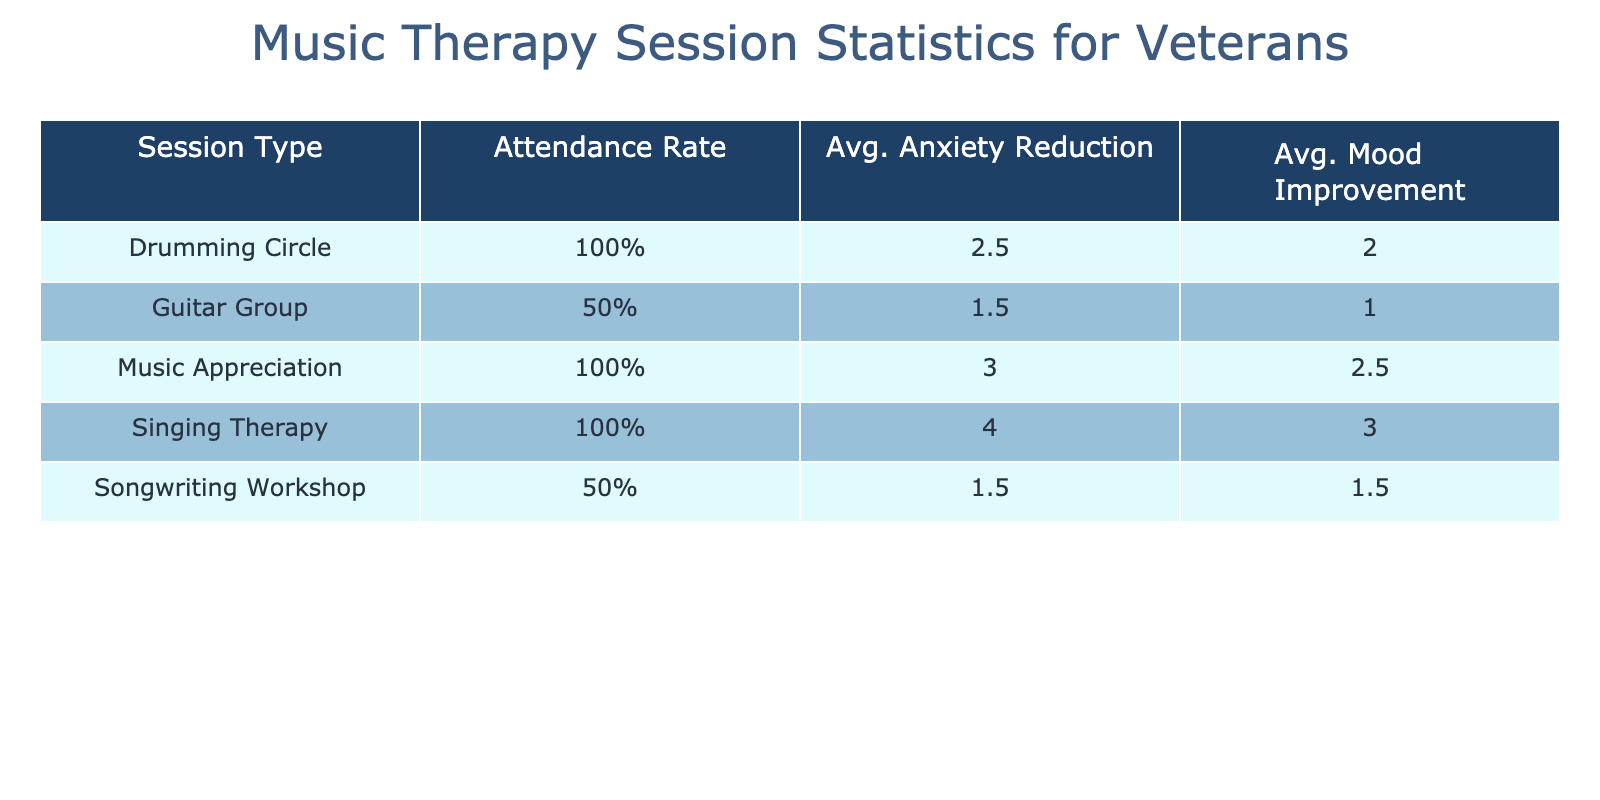What is the attendance rate for the Singing Therapy session type? Looking at the table, the Singing Therapy session had three veterans attending, and all three attended (i.e., 'Yes' for attendance), resulting in an attendance rate of 100%.
Answer: 100% What was the average anxiety reduction for the Drumming Circle session? In the table, the Anxiety Change for the Drumming Circle session (Veterans 001 and 006) is calculated as follows: Veteran 001 had an anxiety level change of 7 - 4 = 3, and Veteran 006 had a change of 4 - 2 = 2. The average is (3 + 2) / 2 = 2.5.
Answer: 2.5 Was there any decrease in mood level after attending the Guitar Group session? For the Guitar Group, only Veteran 008 attended and there is a change in mood level calculated as 6 - 4 = 2, which indicates an improvement in mood. Thus, there was no decrease in mood.
Answer: No What is the average mood improvement across all session types? To find the average mood improvement, we calculate the changes for each session type: Drumming Circle: 1.5, Songwriting Workshop: 3, Music Appreciation: 3, Singing Therapy: 3, and Guitar Group: 2. Since there are 5 sessions, the average improvement is (1.5 + 3 + 3 + 3 + 2) / 5 = 2.1.
Answer: 2.1 How many veterans attended sessions that resulted in an anxiety level reduction of more than 3? Checking each session's Anxiety Change values, only the Drumming Circle (3) and Singing Therapy (4) sessions had reductions greater than 3 and were attended by Veterans 001, 006, and 010. Therefore, the total is 4 veterans who experienced a reduction of more than 3.
Answer: 4 What session type had the highest average mood improvement? Reviewing the Mood Change values: Drumming Circle (1), Songwriting Workshop (2), Music Appreciation (3), Singing Therapy (3), and Guitar Group (2). Music Appreciation and Singing Therapy have the highest average at 3; hence, both these sessions tie as the highest.
Answer: Music Appreciation and Singing Therapy What is the relationship between attendance and anxiety level change in the sessions? Analyzing the table, we notice that the sessions with attendance labeled 'Yes' generally show anxiety reductions: Drumming Circle (3), Singing Therapy (4). In contrast, the Guitar Group session which had a veteran not attending resulted in anxiety levels being higher post-session for anyone who didn't attend. This shows a positive relationship between attendance and anxiety reduction.
Answer: Positive relationship Did the Musical Appreciation session improve mood levels for all participants? The Mood Change for Music Appreciation shows that the changes for Veterans 004 and 009 resulted in an increase of 3 and 2 respectively. Both veterans experienced an improvement, indicating the session positively affected mood levels for all attendees.
Answer: Yes 